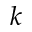Convert formula to latex. <formula><loc_0><loc_0><loc_500><loc_500>k</formula> 